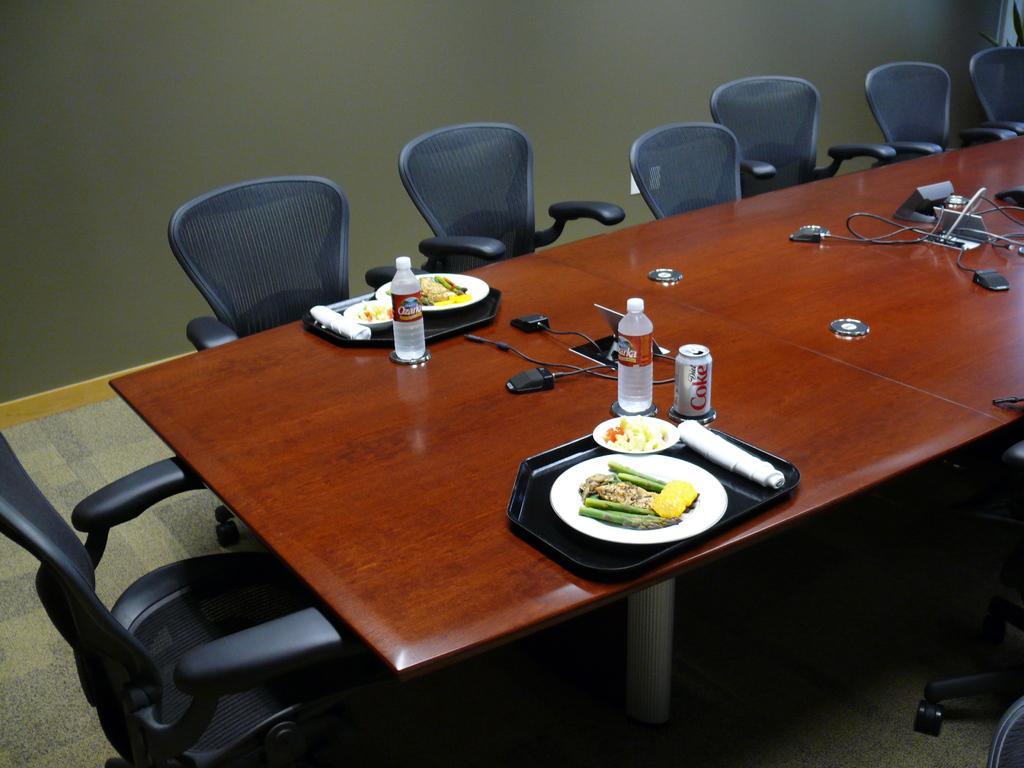Describe this image in one or two sentences. In this image we can see some food items which are in plate on table and there are some water bottles, coke tins and there are some other items, there are chairs around table and in the background of the image there is a wall. 